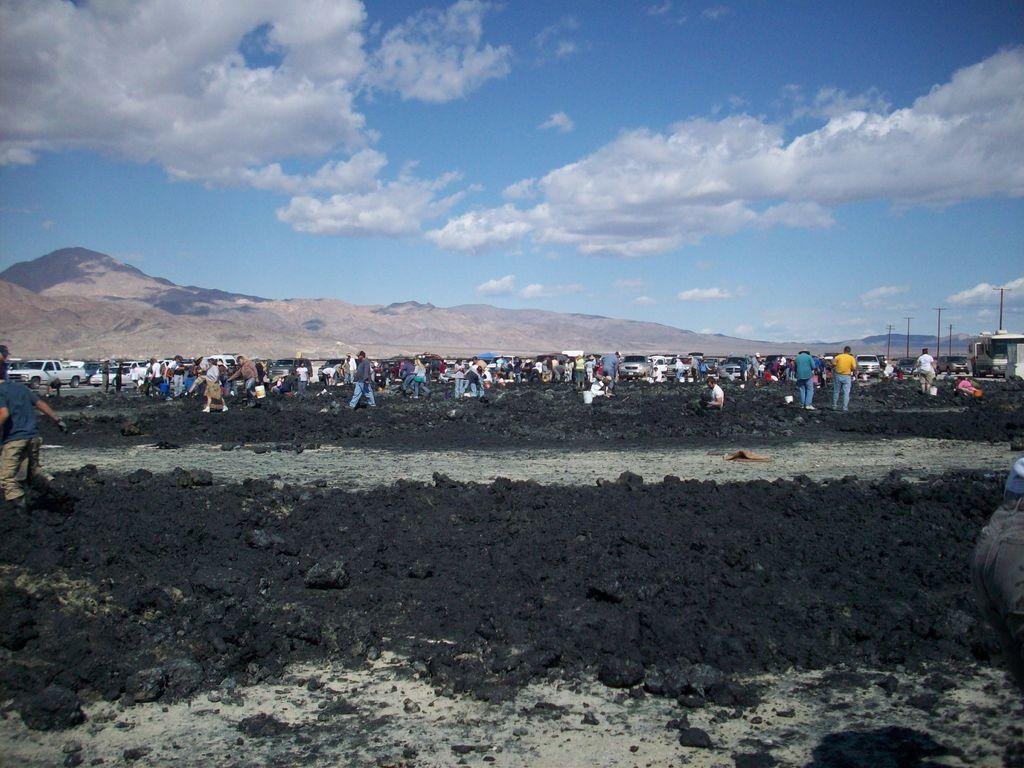What type of surface is visible in the image? There is soil in the image. Who or what can be seen in the image? There are people and vehicles visible in the image. What structures are present in the image? Poles are present in the image. What can be seen in the background of the image? There is a hill and the sky visible in the background of the image. What is the condition of the sky in the image? Clouds are present in the sky. Can you hear the mom whistling in the image? There is no mention of a mom or whistling in the image, so it cannot be heard. 